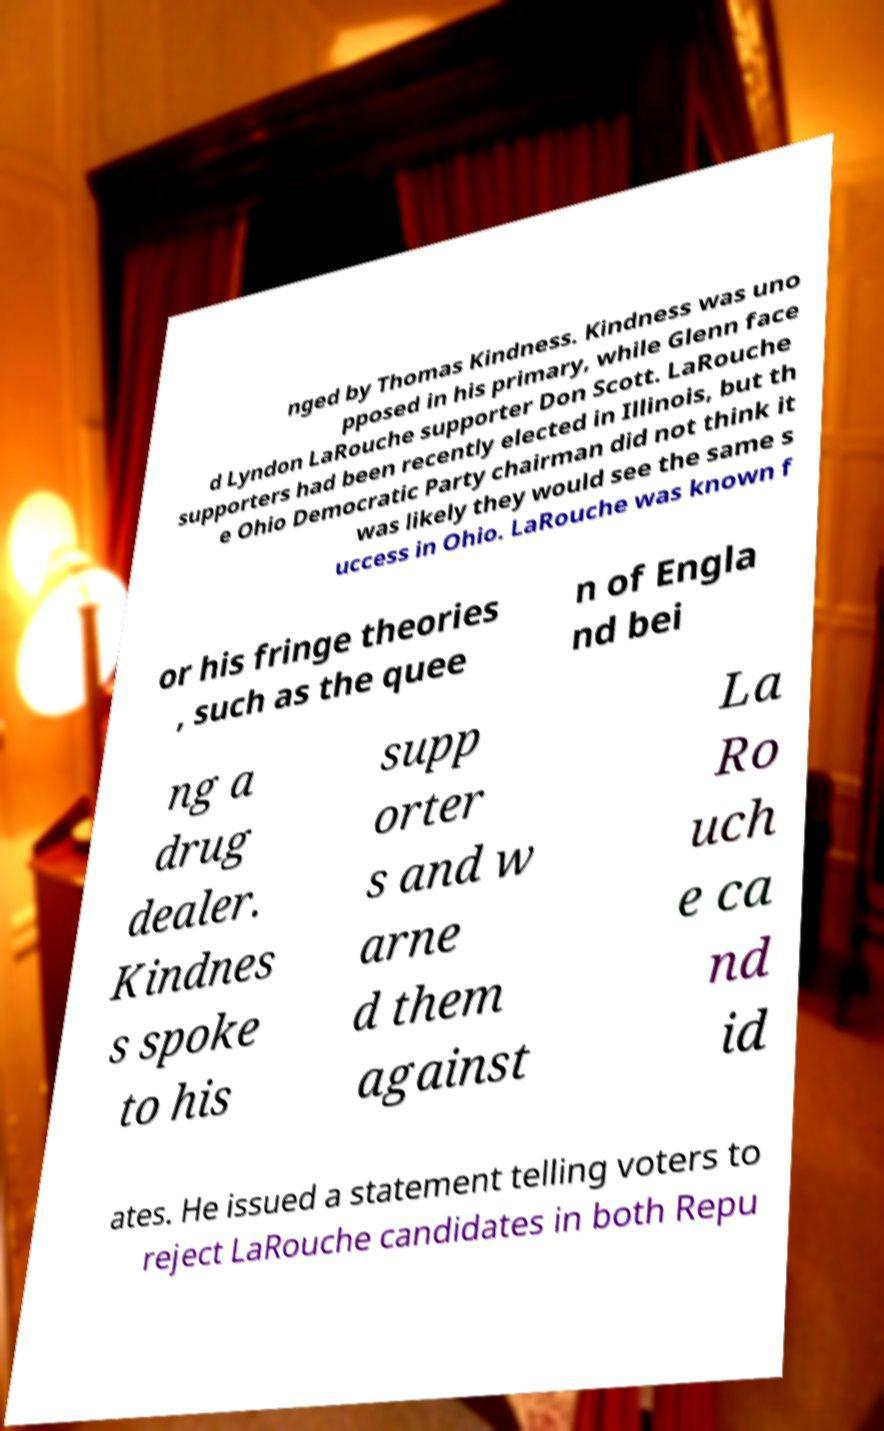There's text embedded in this image that I need extracted. Can you transcribe it verbatim? nged by Thomas Kindness. Kindness was uno pposed in his primary, while Glenn face d Lyndon LaRouche supporter Don Scott. LaRouche supporters had been recently elected in Illinois, but th e Ohio Democratic Party chairman did not think it was likely they would see the same s uccess in Ohio. LaRouche was known f or his fringe theories , such as the quee n of Engla nd bei ng a drug dealer. Kindnes s spoke to his supp orter s and w arne d them against La Ro uch e ca nd id ates. He issued a statement telling voters to reject LaRouche candidates in both Repu 